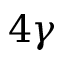<formula> <loc_0><loc_0><loc_500><loc_500>{ 4 \gamma }</formula> 